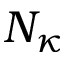<formula> <loc_0><loc_0><loc_500><loc_500>N _ { \kappa }</formula> 